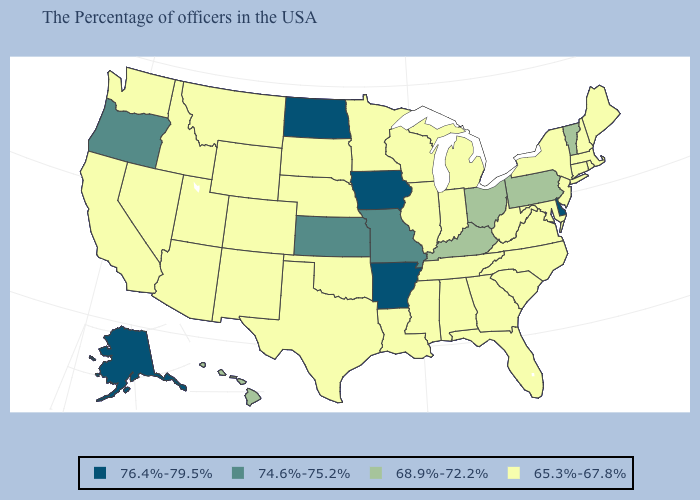What is the value of Minnesota?
Keep it brief. 65.3%-67.8%. What is the value of New York?
Be succinct. 65.3%-67.8%. Among the states that border Delaware , does Maryland have the lowest value?
Be succinct. Yes. What is the value of New York?
Quick response, please. 65.3%-67.8%. Name the states that have a value in the range 74.6%-75.2%?
Write a very short answer. Missouri, Kansas, Oregon. Name the states that have a value in the range 74.6%-75.2%?
Write a very short answer. Missouri, Kansas, Oregon. Does North Dakota have the lowest value in the USA?
Concise answer only. No. What is the value of Washington?
Concise answer only. 65.3%-67.8%. Among the states that border Mississippi , does Louisiana have the highest value?
Concise answer only. No. What is the value of New Hampshire?
Be succinct. 65.3%-67.8%. Does the map have missing data?
Be succinct. No. What is the lowest value in the West?
Quick response, please. 65.3%-67.8%. Name the states that have a value in the range 76.4%-79.5%?
Quick response, please. Delaware, Arkansas, Iowa, North Dakota, Alaska. Name the states that have a value in the range 74.6%-75.2%?
Answer briefly. Missouri, Kansas, Oregon. Among the states that border Massachusetts , does Connecticut have the highest value?
Quick response, please. No. 